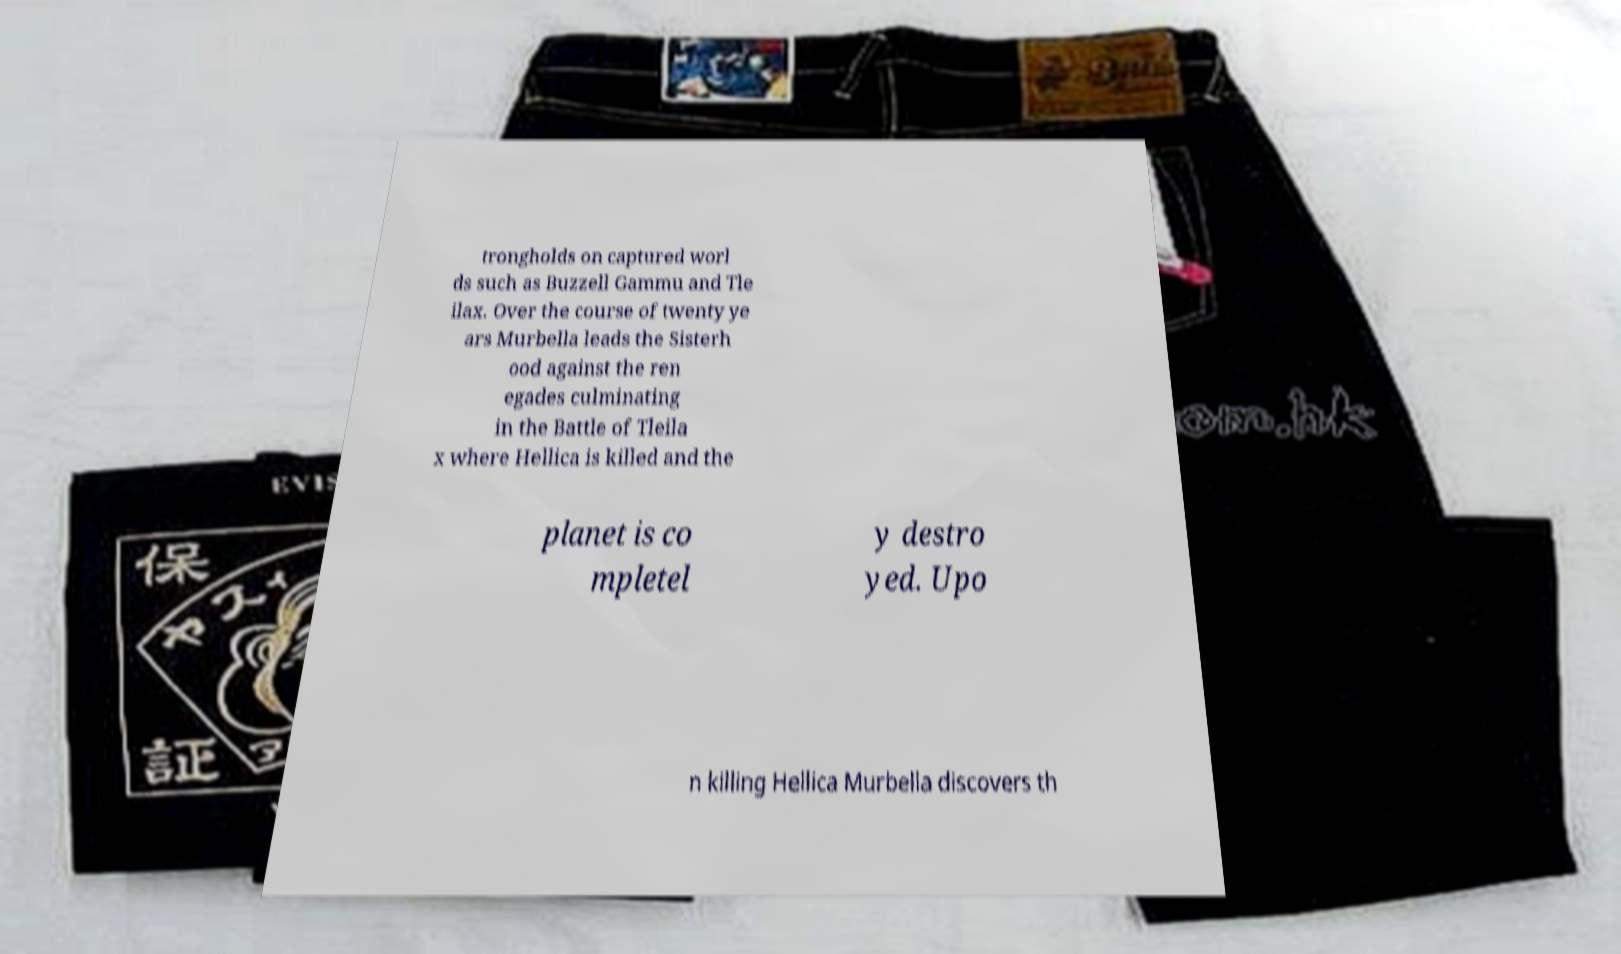I need the written content from this picture converted into text. Can you do that? trongholds on captured worl ds such as Buzzell Gammu and Tle ilax. Over the course of twenty ye ars Murbella leads the Sisterh ood against the ren egades culminating in the Battle of Tleila x where Hellica is killed and the planet is co mpletel y destro yed. Upo n killing Hellica Murbella discovers th 